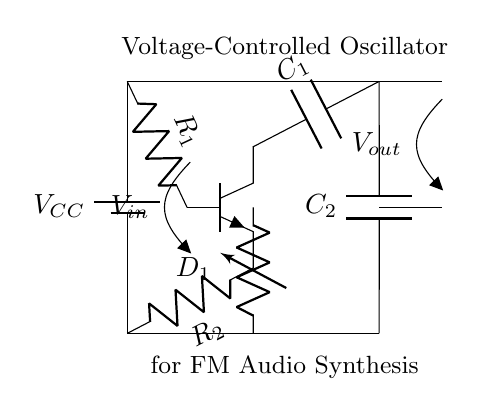What is the power supply voltage in this circuit? The power supply voltage is represented as \( V_{CC} \) in the circuit diagram. It typically provides the necessary voltage for the operation of the circuit components.
Answer: \( V_{CC} \) What type of transistor is used in this circuit? The circuit uses an NPN transistor, as indicated by the label on the diagram. This is important for controlling current flow from the collector to the emitter when a voltage is applied to the base.
Answer: NPN What are the values of the capacitors in the circuit? The circuit diagram does not specify numerical values for the capacitors \( C_1 \) and \( C_2 \), but they are crucial for setting the frequency of oscillation in the circuit. Therefore, the specific values are typically needed from an external source or design specifications.
Answer: Not specified How does the varactor diode function in this oscillator? The varactor diode \( D_1 \) is used to change the capacitance based on the voltage applied, which allows for frequency modulation in the oscillator circuit. The capacitance variation directly affects the oscillation frequency, enabling this functionality.
Answer: Frequency modulation Which components are used to set the frequency of the oscillator? The components that set the frequency of the oscillator are capacitors \( C_1 \) and \( C_2 \), as well as the varactor diode \( D_1 \). These components work together to determine the oscillation frequency by influencing the feedback and timing characteristics of the circuit.
Answer: Capacitors and varactor diode What is the function of resistor \( R_1 \) in this circuit? Resistor \( R_1 \) is connected to the base of the transistor and is critical for biasing the transistor to ensure it operates in the correct region for oscillation, which allows the circuit to function effectively as a voltage-controlled oscillator.
Answer: Biasing the transistor How does varying the input voltage \( V_{in} \) affect the output frequency? Varying the input voltage \( V_{in} \) changes the voltage across the varactor diode, which alters its capacitance. This change in capacitance modifies the frequency of oscillation in the circuit, enabling control over the output frequency based on the input voltage.
Answer: Changes the oscillation frequency 